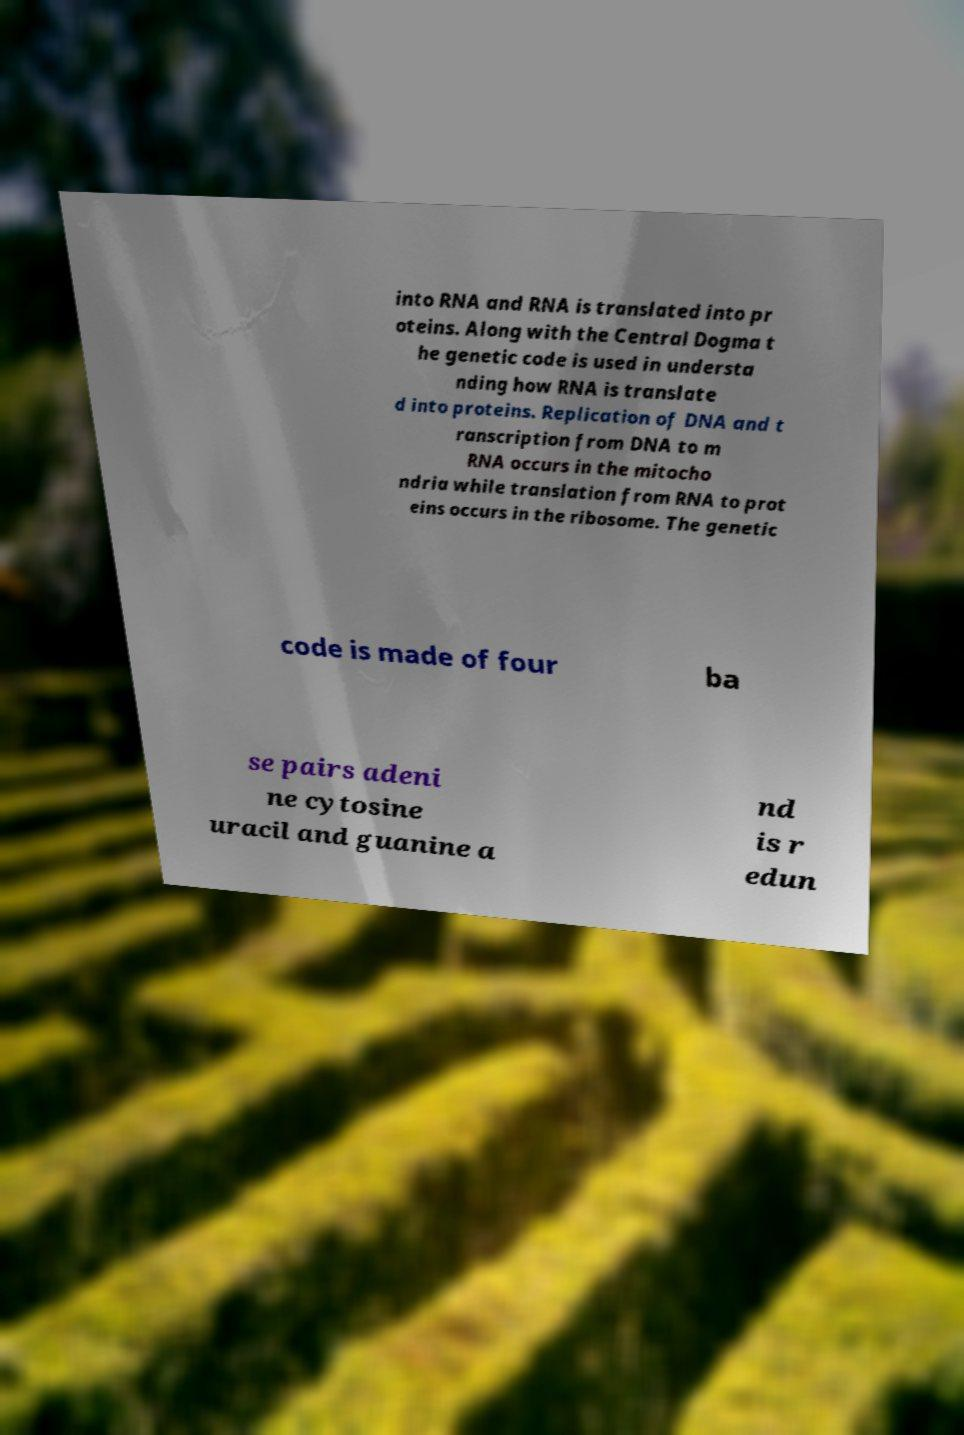Can you read and provide the text displayed in the image?This photo seems to have some interesting text. Can you extract and type it out for me? into RNA and RNA is translated into pr oteins. Along with the Central Dogma t he genetic code is used in understa nding how RNA is translate d into proteins. Replication of DNA and t ranscription from DNA to m RNA occurs in the mitocho ndria while translation from RNA to prot eins occurs in the ribosome. The genetic code is made of four ba se pairs adeni ne cytosine uracil and guanine a nd is r edun 